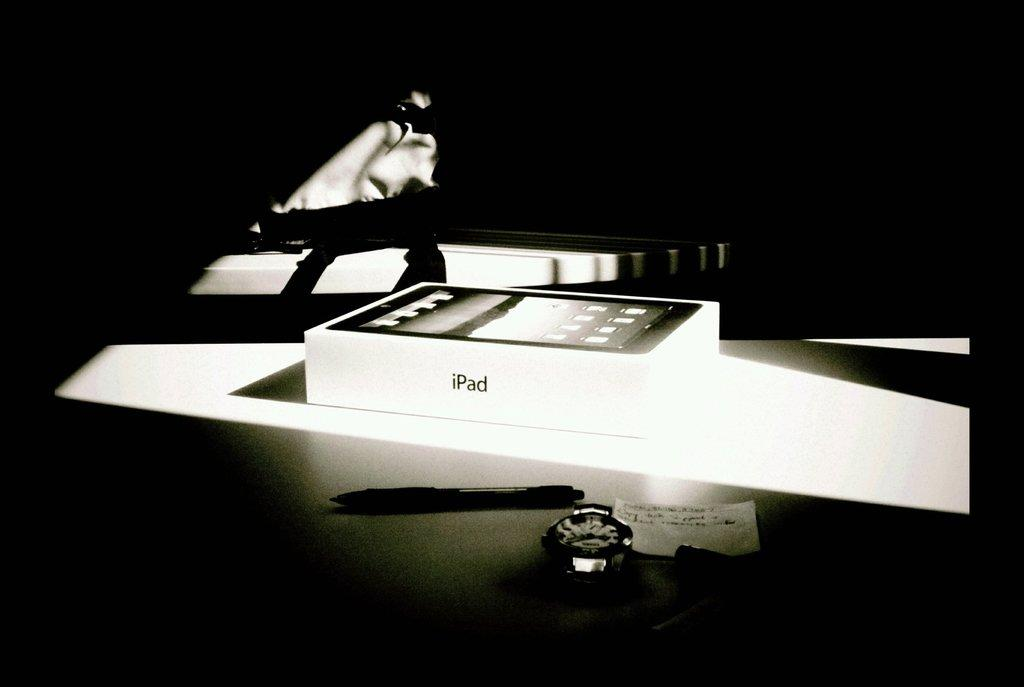<image>
Describe the image concisely. A white Ipad is on display in a dark photo 